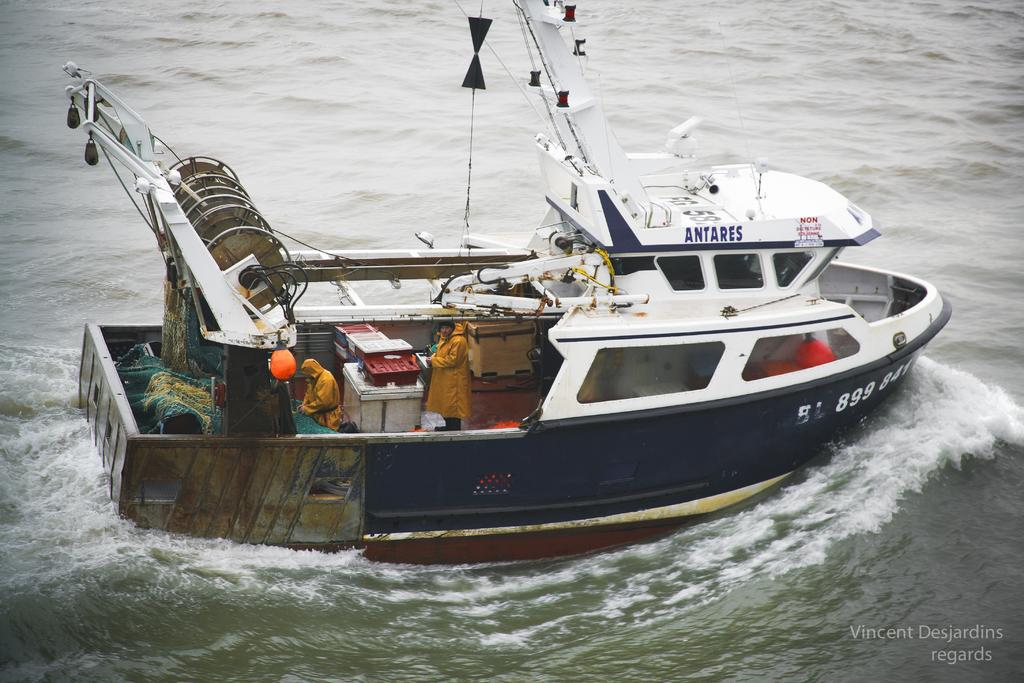What is the main subject of the image? The main subject of the image is a boat. Where is the boat located? The boat is in the water. What color is the boat? The boat is white in color. Are there any people in the boat? Yes, there are people inside the boat. What type of toad can be seen performing a cast in the image? There is no toad or any reference to a cast in the image; it features a white boat with people inside. 